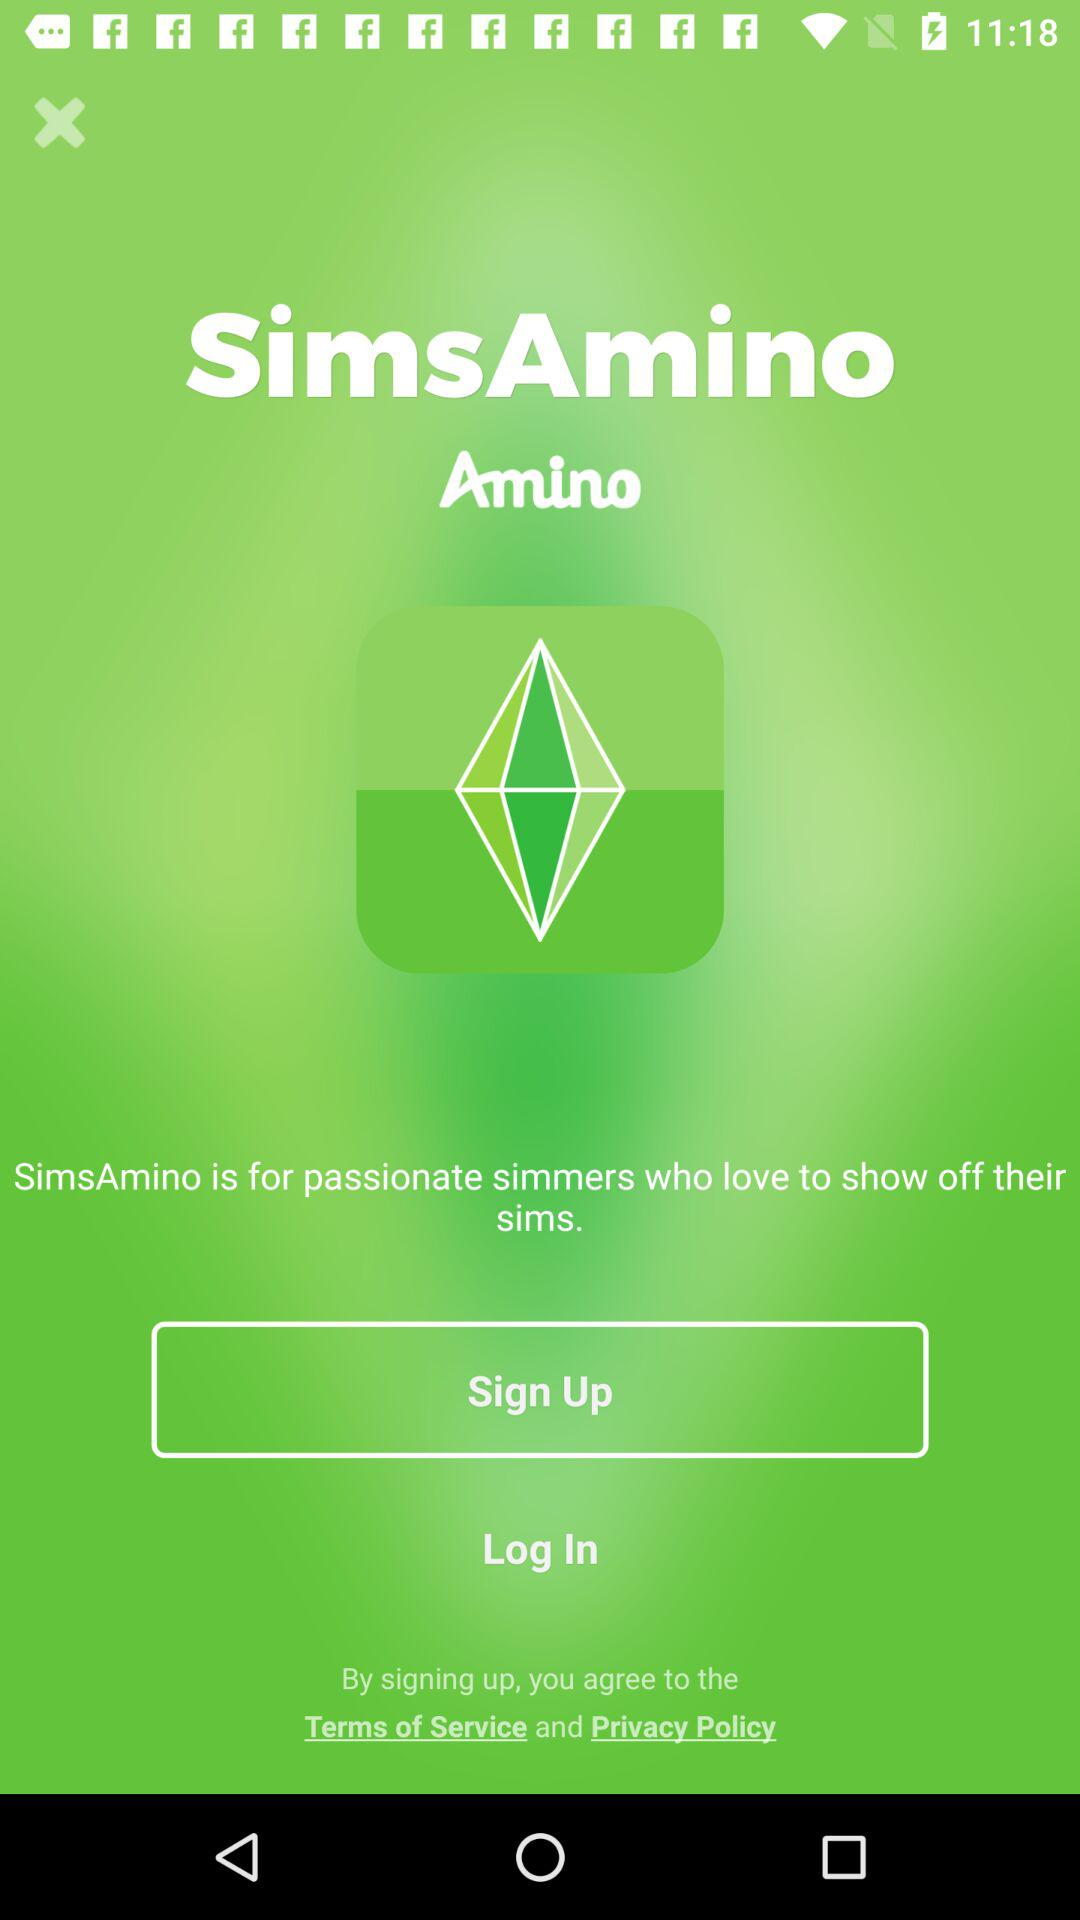What is the app name? The app name is "SimsAmino". 